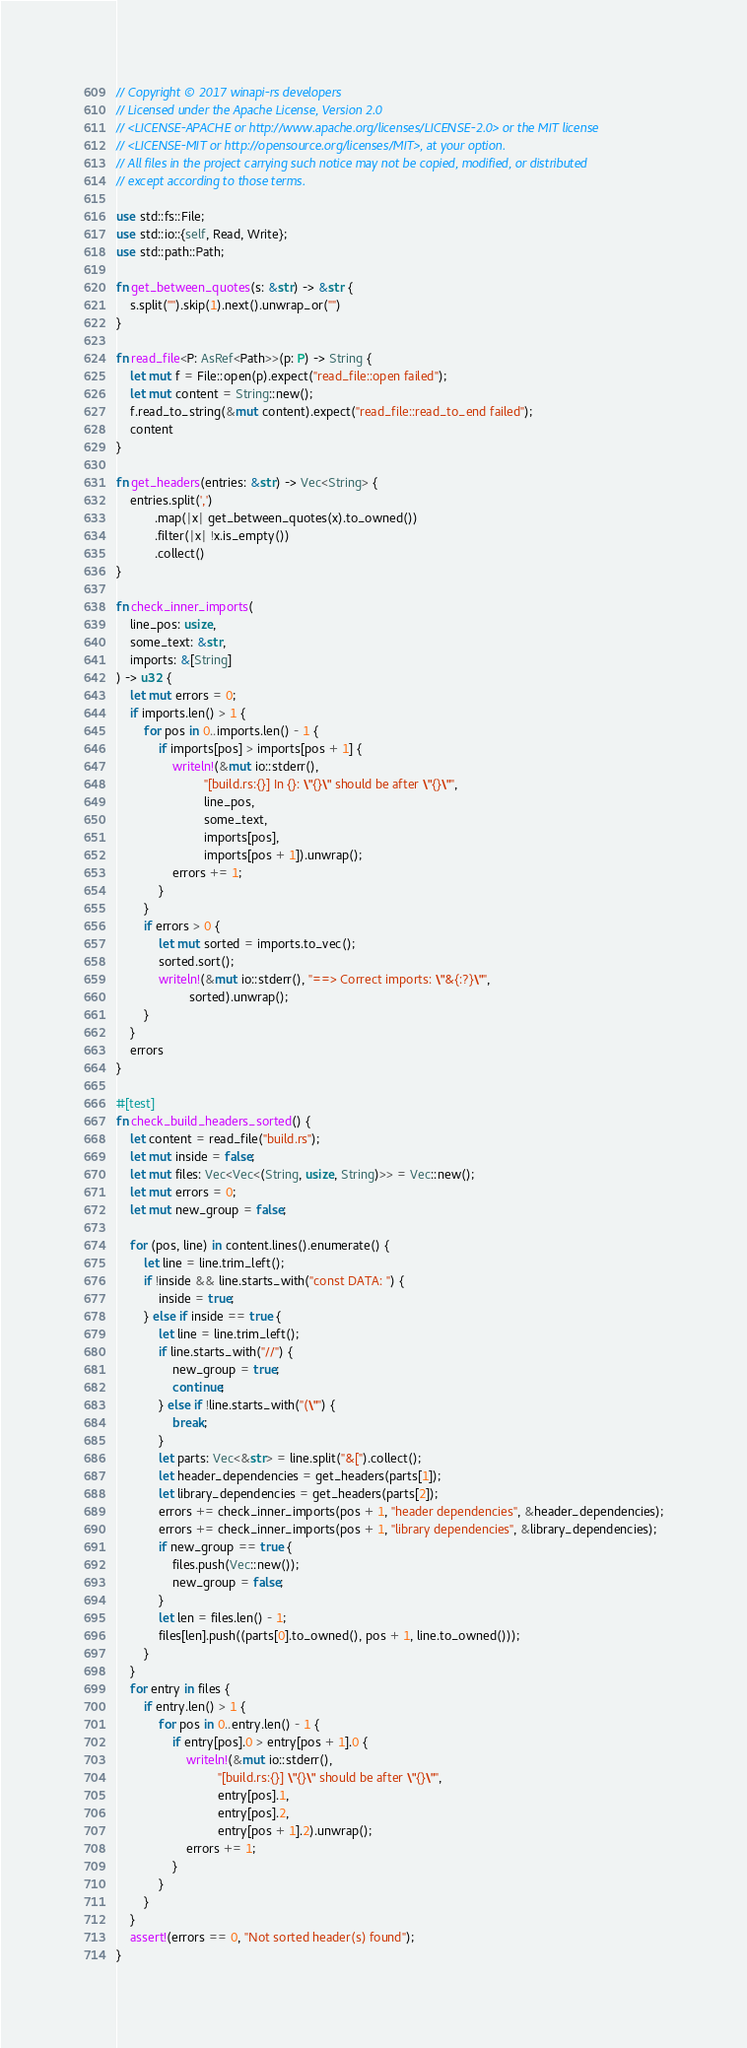Convert code to text. <code><loc_0><loc_0><loc_500><loc_500><_Rust_>// Copyright © 2017 winapi-rs developers
// Licensed under the Apache License, Version 2.0
// <LICENSE-APACHE or http://www.apache.org/licenses/LICENSE-2.0> or the MIT license
// <LICENSE-MIT or http://opensource.org/licenses/MIT>, at your option.
// All files in the project carrying such notice may not be copied, modified, or distributed
// except according to those terms.

use std::fs::File;
use std::io::{self, Read, Write};
use std::path::Path;

fn get_between_quotes(s: &str) -> &str {
    s.split('"').skip(1).next().unwrap_or("")
}

fn read_file<P: AsRef<Path>>(p: P) -> String {
    let mut f = File::open(p).expect("read_file::open failed");
    let mut content = String::new();
    f.read_to_string(&mut content).expect("read_file::read_to_end failed");
    content
}

fn get_headers(entries: &str) -> Vec<String> {
    entries.split(',')
           .map(|x| get_between_quotes(x).to_owned())
           .filter(|x| !x.is_empty())
           .collect()
}

fn check_inner_imports(
    line_pos: usize,
    some_text: &str,
    imports: &[String]
) -> u32 {
    let mut errors = 0;
    if imports.len() > 1 {
        for pos in 0..imports.len() - 1 {
            if imports[pos] > imports[pos + 1] {
                writeln!(&mut io::stderr(),
                         "[build.rs:{}] In {}: \"{}\" should be after \"{}\"",
                         line_pos,
                         some_text,
                         imports[pos],
                         imports[pos + 1]).unwrap();
                errors += 1;
            }
        }
        if errors > 0 {
            let mut sorted = imports.to_vec();
            sorted.sort();
            writeln!(&mut io::stderr(), "==> Correct imports: \"&{:?}\"",
                     sorted).unwrap();
        }
    }
    errors
}

#[test]
fn check_build_headers_sorted() {
    let content = read_file("build.rs");
    let mut inside = false;
    let mut files: Vec<Vec<(String, usize, String)>> = Vec::new();
    let mut errors = 0;
    let mut new_group = false;

    for (pos, line) in content.lines().enumerate() {
        let line = line.trim_left();
        if !inside && line.starts_with("const DATA: ") {
            inside = true;
        } else if inside == true {
            let line = line.trim_left();
            if line.starts_with("//") {
                new_group = true;
                continue;
            } else if !line.starts_with("(\"") {
                break;
            }
            let parts: Vec<&str> = line.split("&[").collect();
            let header_dependencies = get_headers(parts[1]);
            let library_dependencies = get_headers(parts[2]);
            errors += check_inner_imports(pos + 1, "header dependencies", &header_dependencies);
            errors += check_inner_imports(pos + 1, "library dependencies", &library_dependencies);
            if new_group == true {
                files.push(Vec::new());
                new_group = false;
            }
            let len = files.len() - 1;
            files[len].push((parts[0].to_owned(), pos + 1, line.to_owned()));
        }
    }
    for entry in files {
        if entry.len() > 1 {
            for pos in 0..entry.len() - 1 {
                if entry[pos].0 > entry[pos + 1].0 {
                    writeln!(&mut io::stderr(),
                             "[build.rs:{}] \"{}\" should be after \"{}\"",
                             entry[pos].1,
                             entry[pos].2,
                             entry[pos + 1].2).unwrap();
                    errors += 1;
                }
            }
        }
    }
    assert!(errors == 0, "Not sorted header(s) found");
}
</code> 